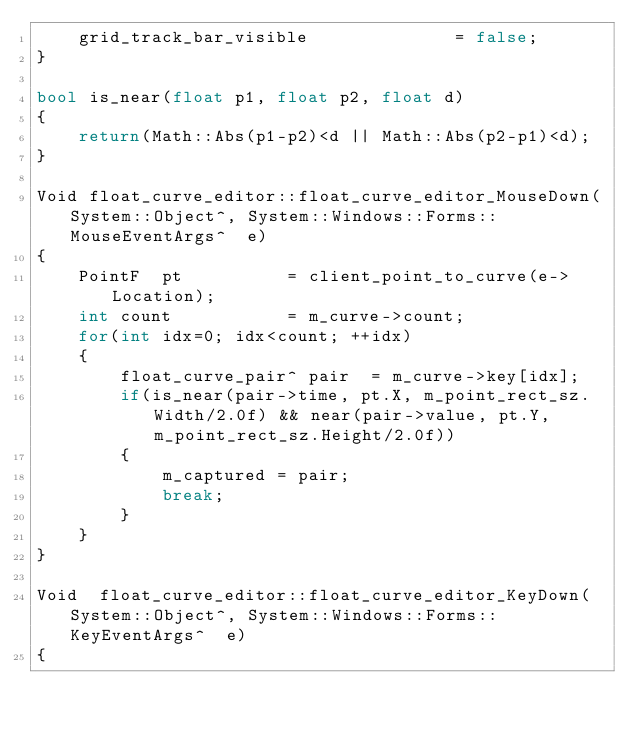<code> <loc_0><loc_0><loc_500><loc_500><_C++_>	grid_track_bar_visible				= false;
}

bool is_near(float p1, float p2, float d)
{
	return(Math::Abs(p1-p2)<d || Math::Abs(p2-p1)<d);
}

Void float_curve_editor::float_curve_editor_MouseDown(System::Object^, System::Windows::Forms::MouseEventArgs^  e)
{
	PointF  pt			= client_point_to_curve(e->Location);
	int count			= m_curve->count;
	for(int idx=0; idx<count; ++idx)
	{
		float_curve_pair^ pair	= m_curve->key[idx];
		if(is_near(pair->time, pt.X, m_point_rect_sz.Width/2.0f) && near(pair->value, pt.Y, m_point_rect_sz.Height/2.0f))
		{
			m_captured = pair;
			break;
		}
	}
}

Void  float_curve_editor::float_curve_editor_KeyDown(System::Object^, System::Windows::Forms::KeyEventArgs^  e)
{</code> 